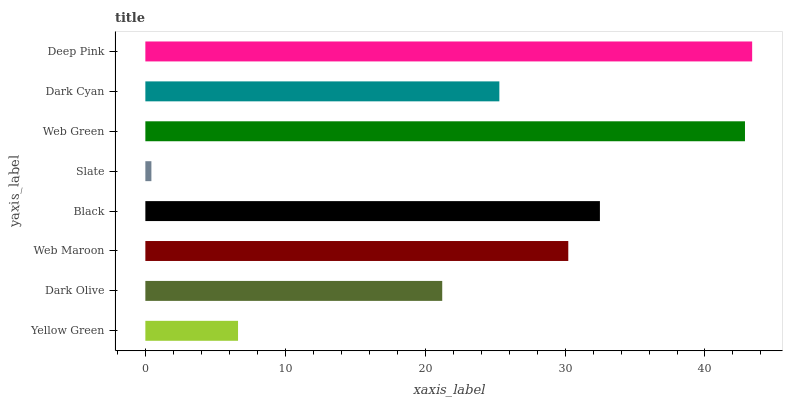Is Slate the minimum?
Answer yes or no. Yes. Is Deep Pink the maximum?
Answer yes or no. Yes. Is Dark Olive the minimum?
Answer yes or no. No. Is Dark Olive the maximum?
Answer yes or no. No. Is Dark Olive greater than Yellow Green?
Answer yes or no. Yes. Is Yellow Green less than Dark Olive?
Answer yes or no. Yes. Is Yellow Green greater than Dark Olive?
Answer yes or no. No. Is Dark Olive less than Yellow Green?
Answer yes or no. No. Is Web Maroon the high median?
Answer yes or no. Yes. Is Dark Cyan the low median?
Answer yes or no. Yes. Is Dark Olive the high median?
Answer yes or no. No. Is Yellow Green the low median?
Answer yes or no. No. 